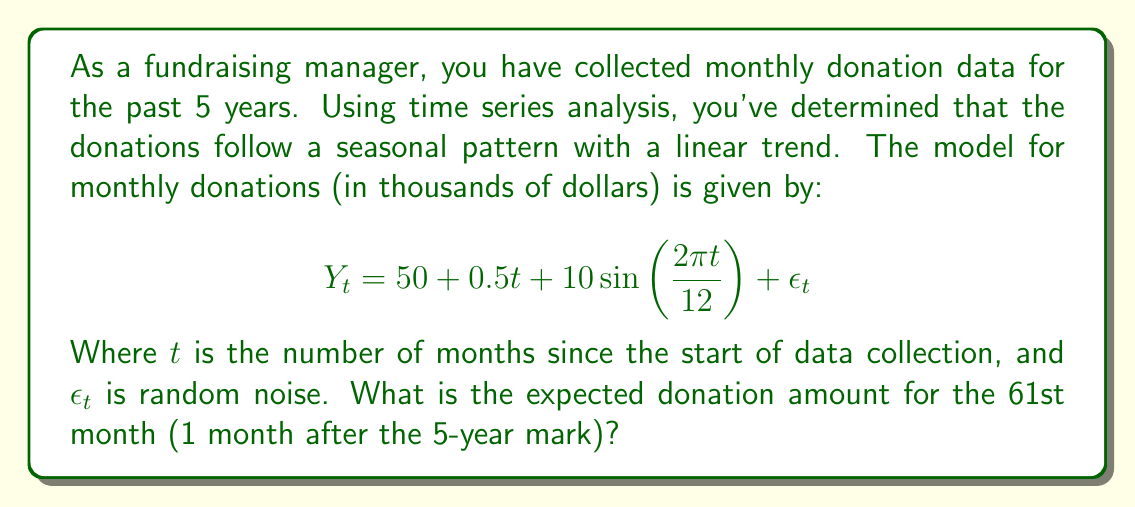Can you answer this question? To solve this problem, we need to follow these steps:

1. Identify the components of the time series model:
   - Intercept: $50$
   - Linear trend: $0.5t$
   - Seasonal component: $10\sin(\frac{2\pi t}{12})$
   - $\epsilon_t$ is random noise, which we ignore for forecasting

2. Substitute $t = 61$ into the equation:

   $$Y_{61} = 50 + 0.5(61) + 10\sin(\frac{2\pi (61)}{12})$$

3. Calculate the linear trend component:
   $50 + 0.5(61) = 50 + 30.5 = 80.5$

4. Calculate the seasonal component:
   $10\sin(\frac{2\pi (61)}{12}) = 10\sin(31.94\pi) \approx 10\sin(-0.06\pi) \approx -1.88$

5. Sum up the components:
   $80.5 + (-1.88) = 78.62$

Therefore, the expected donation amount for the 61st month is approximately $78,620.
Answer: $78.62$ thousand dollars 